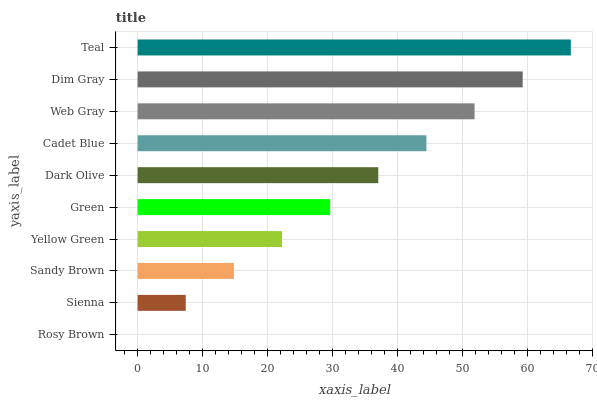Is Rosy Brown the minimum?
Answer yes or no. Yes. Is Teal the maximum?
Answer yes or no. Yes. Is Sienna the minimum?
Answer yes or no. No. Is Sienna the maximum?
Answer yes or no. No. Is Sienna greater than Rosy Brown?
Answer yes or no. Yes. Is Rosy Brown less than Sienna?
Answer yes or no. Yes. Is Rosy Brown greater than Sienna?
Answer yes or no. No. Is Sienna less than Rosy Brown?
Answer yes or no. No. Is Dark Olive the high median?
Answer yes or no. Yes. Is Green the low median?
Answer yes or no. Yes. Is Teal the high median?
Answer yes or no. No. Is Web Gray the low median?
Answer yes or no. No. 